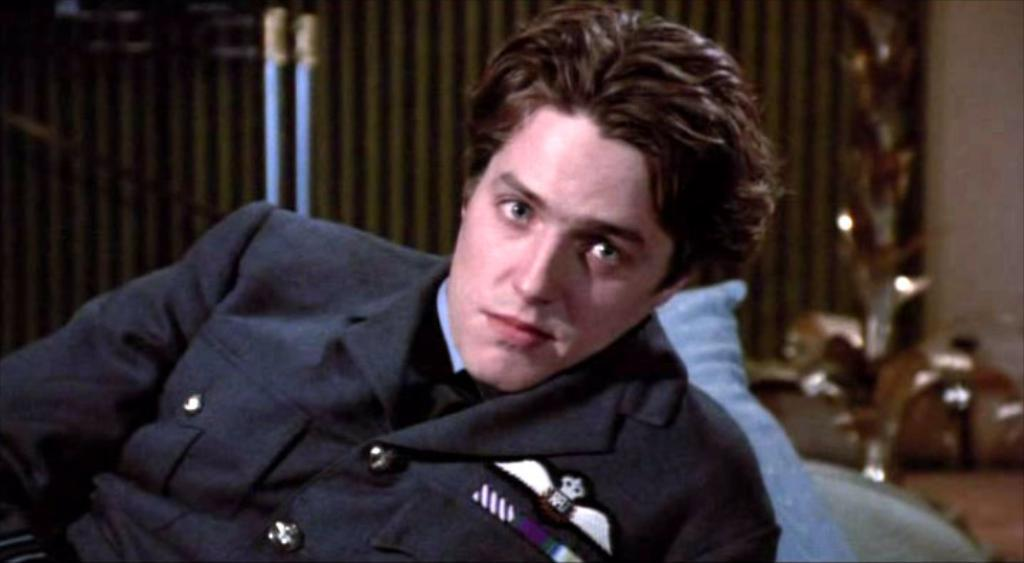Who or what is present in the image? There is a person in the image. What color is the object that can be seen in the image? There is a blue colored object in the image. What can be seen on the ground in the image? The ground is visible in the image with some objects. What is visible in the background of the image? There is a wall in the background of the image with some objects. Can you see a donkey in the nest in the image? There is no donkey or nest present in the image. 